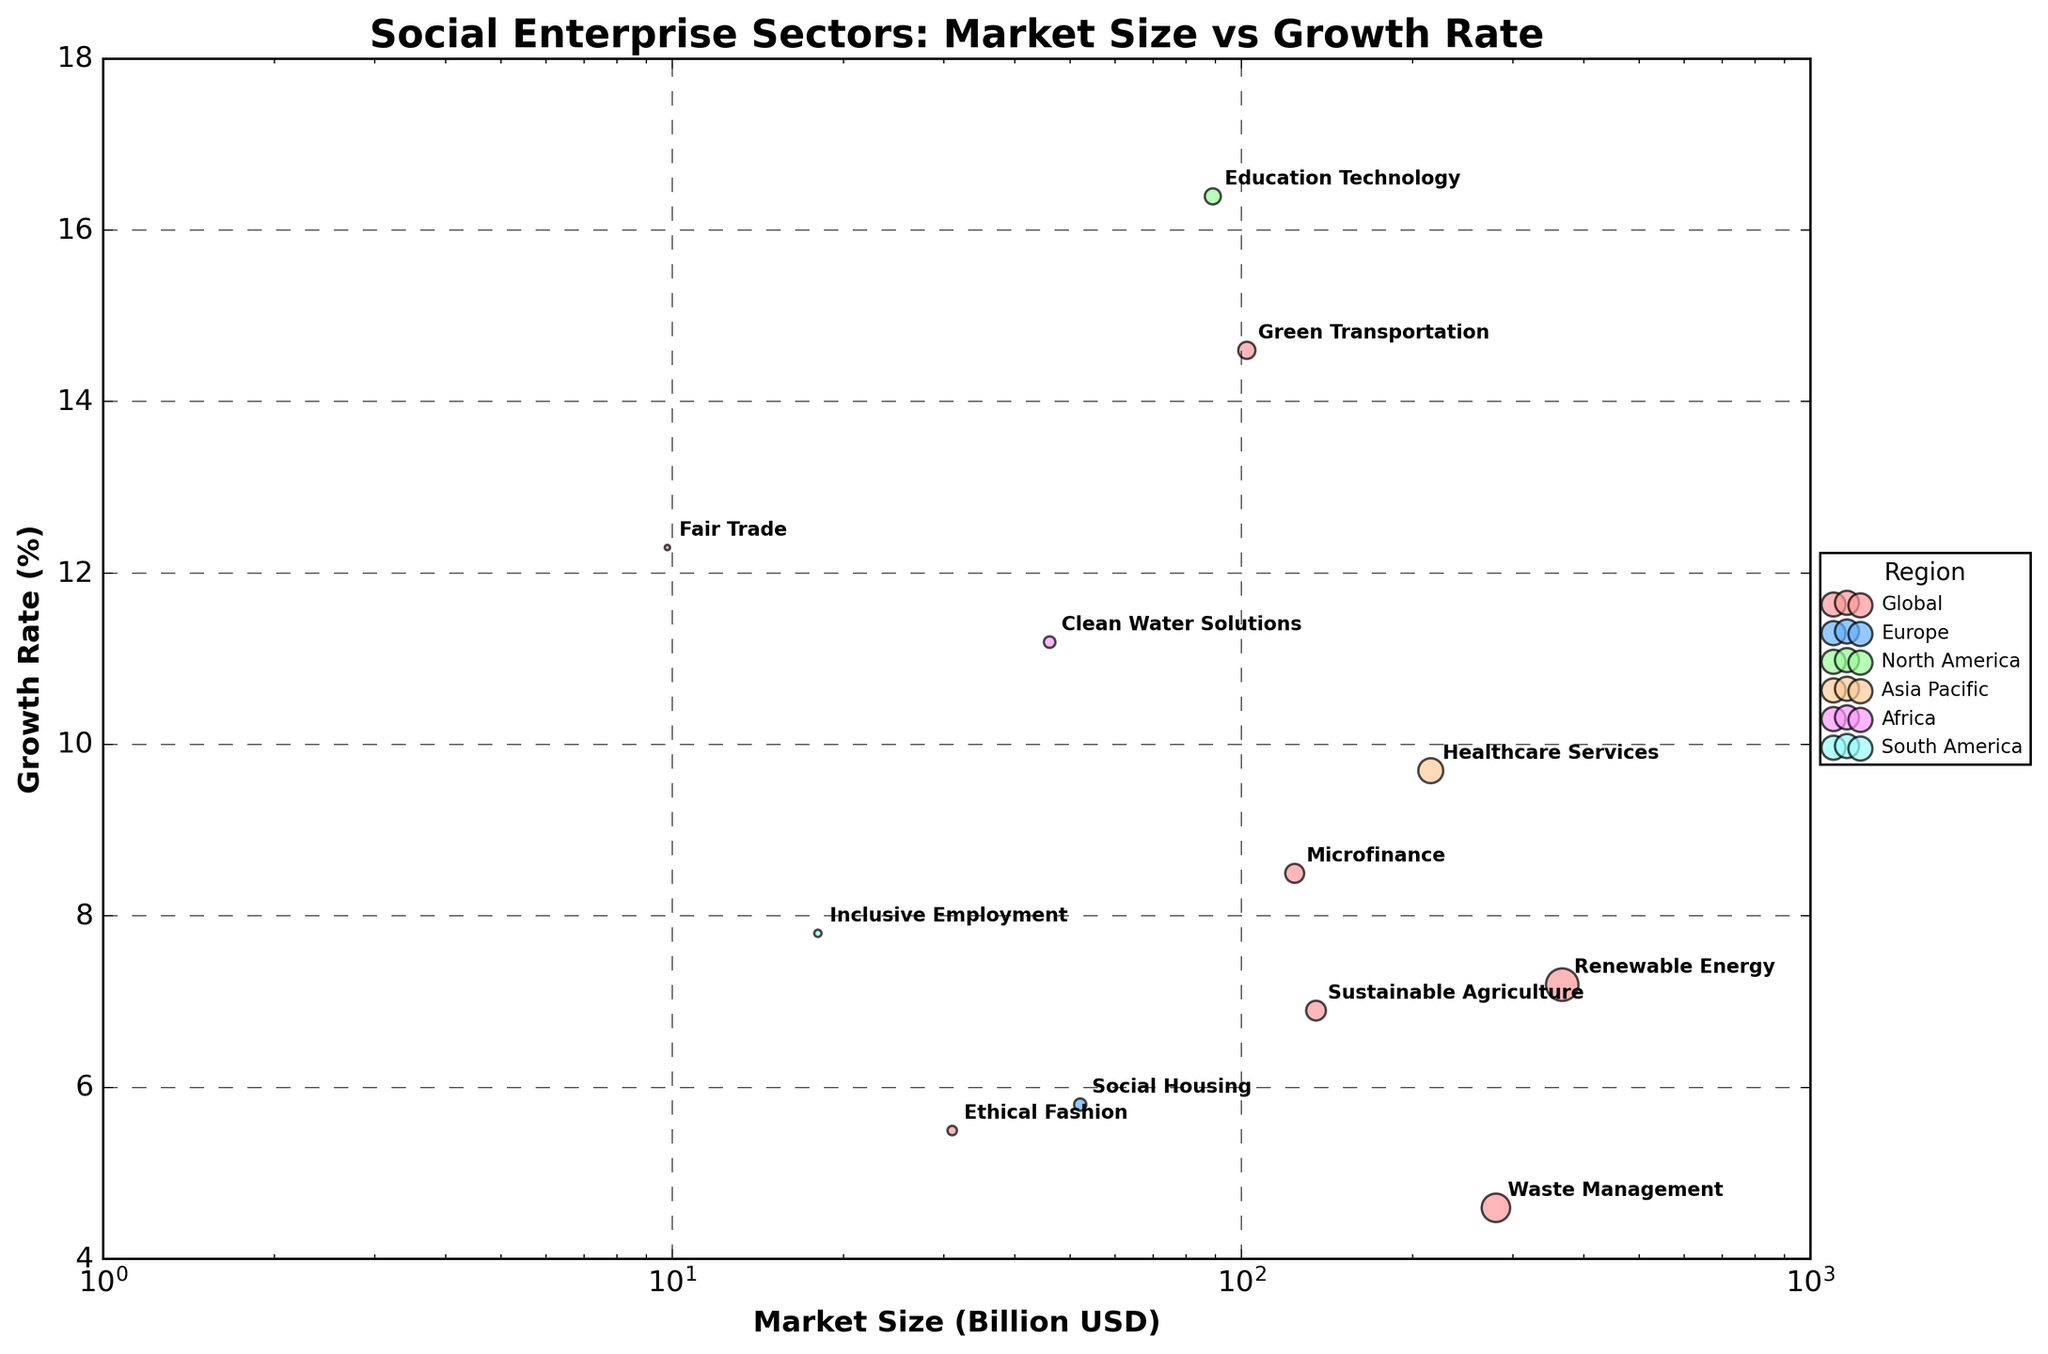What's the title of the figure? The title of the figure is typically located at the top center of the plot. Upon inspecting the figure, it reads "Social Enterprise Sectors: Market Size vs Growth Rate".
Answer: Social Enterprise Sectors: Market Size vs Growth Rate What does the x-axis represent? The x-axis typically runs horizontally at the bottom of the plot. Here, it represents "Market Size (Billion USD)".
Answer: Market Size (Billion USD) Which sector has the largest market size? From the bubble chart, the sector with the highest value on the x-axis represents the largest market size. "Renewable Energy" is the sector with the largest market size at 366 Billion USD.
Answer: Renewable Energy Which region has the most sectors represented? By examining the color coding of bubbles and the legend, we can see which colors are most frequent. The "Global" region, represented by a type of pink color, has the most sectors.
Answer: Global What is the growth rate of Microfinance? To answer this, locate the bubble labeled "Microfinance" and note its position on the y-axis. The growth rate is 8.5%.
Answer: 8.5% How many sectors have a market size greater than 100 Billion USD? Count the bubbles that lie to the right of the 100 Billion USD mark on the x-axis. Renewable Energy, Microfinance, Healthcare Services, Green Transportation, Waste Management, Sustainable Agriculture, and Education Technology - totaling 7 sectors.
Answer: 7 What is the smallest market size depicted, and which sector does it represent? Identify the leftmost bubble on the x-axis. The smallest market size is associated with "Fair Trade", at 9.8 Billion USD.
Answer: Fair Trade Which sector has the highest growth rate, and how much is it? Find the highest point on the y-axis and refer to the bubble's label. "Education Technology" has the highest growth rate at 16.4%.
Answer: Education Technology Compare the market sizes and growth rates of Ethical Fashion and Social Housing. Ethical Fashion has a market size of 31 Billion USD and a growth rate of 5.5%. Social Housing has a market size of 52 Billion USD and a growth rate of 5.8%. Social Housing has both a larger market size and a higher growth rate.
Answer: Social Housing What is the average growth rate of sectors in North America and Europe? Calculate the mean of the growth rates for sectors in North America and Europe. Education Technology (16.4%) from North America and Social Housing (5.8%) from Europe. The average is (16.4 + 5.8) / 2 = 11.1%.
Answer: 11.1% 